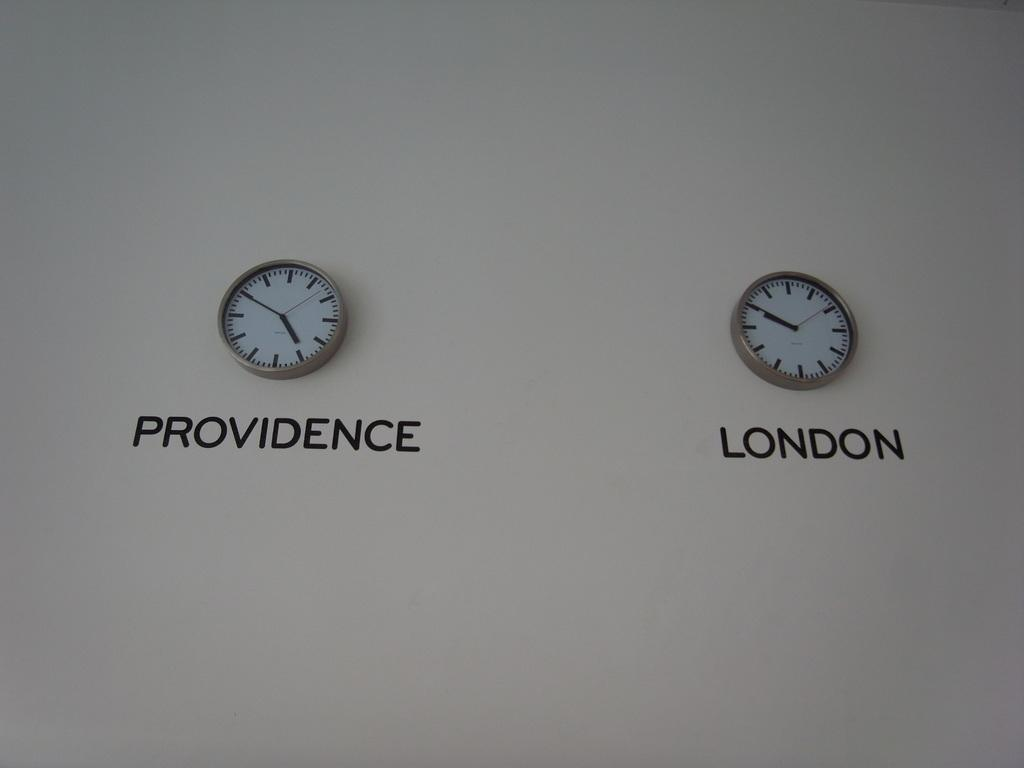<image>
Give a short and clear explanation of the subsequent image. A clock that says Providence and a clock that says London on a wall. 